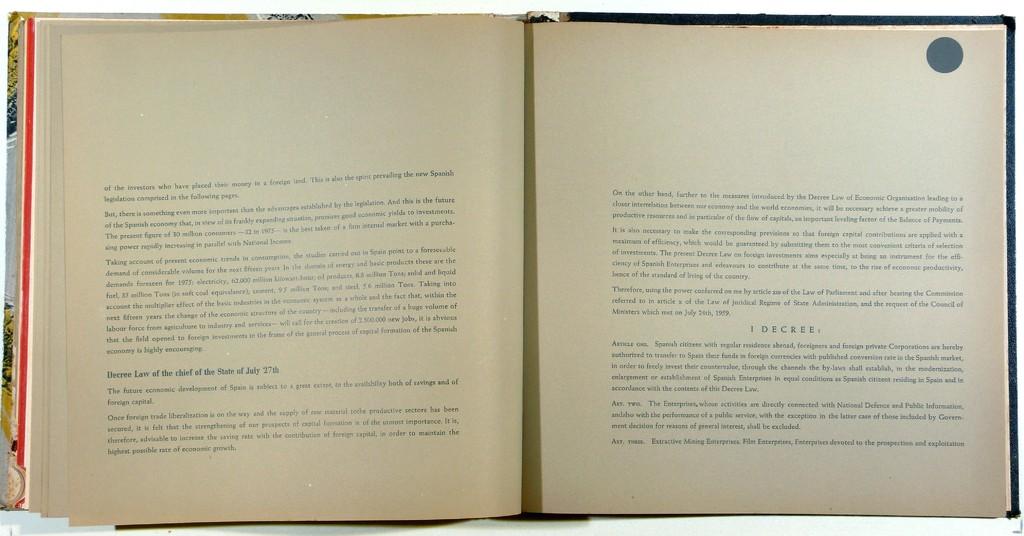What's the first word in this chapter?
Provide a succinct answer. Of. 